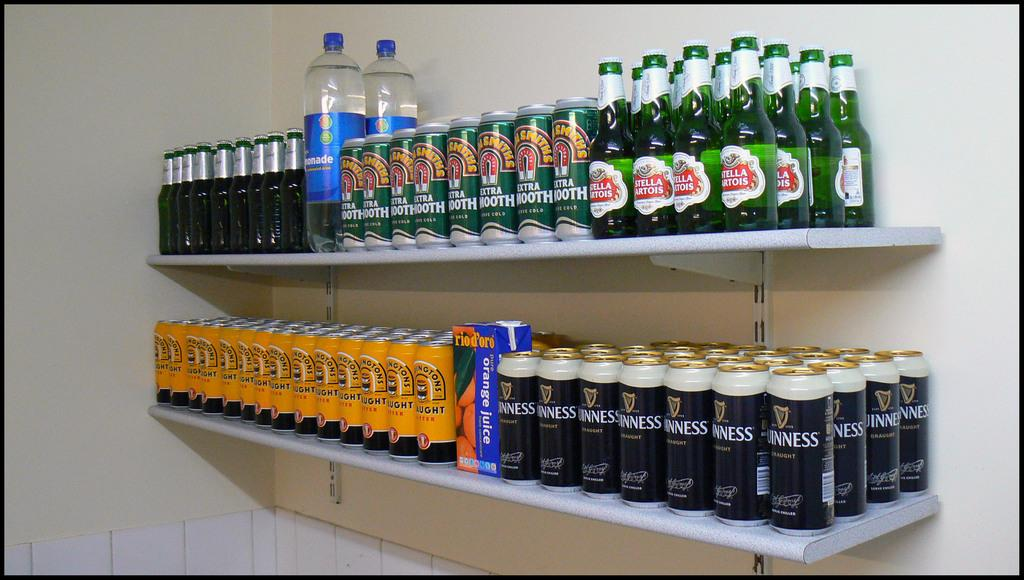What type of storage unit is visible in the image? There is a shelf in the image. What items can be seen on the shelf? The shelf contains tins, bottles, and water bottles. What is the background of the image? There is a wall in the background of the image. What type of pain can be seen on the shelf in the image? There is no pain present on the shelf in the image; it contains tins, bottles, and water bottles. Is there any eggnog visible on the shelf in the image? There is no eggnog present on the shelf in the image; it contains tins, bottles, and water bottles. 